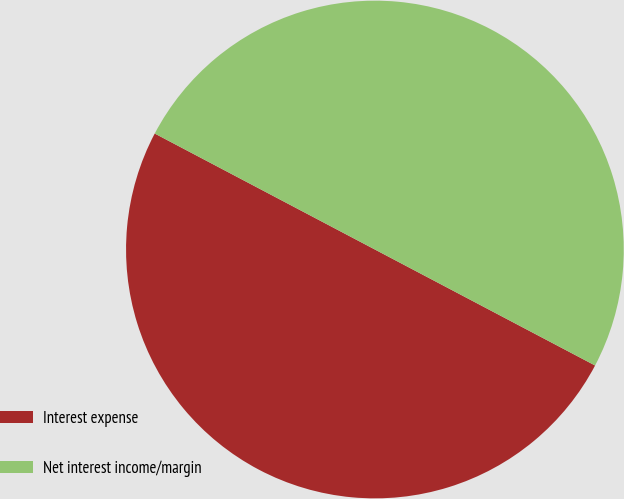Convert chart. <chart><loc_0><loc_0><loc_500><loc_500><pie_chart><fcel>Interest expense<fcel>Net interest income/margin<nl><fcel>50.0%<fcel>50.0%<nl></chart> 